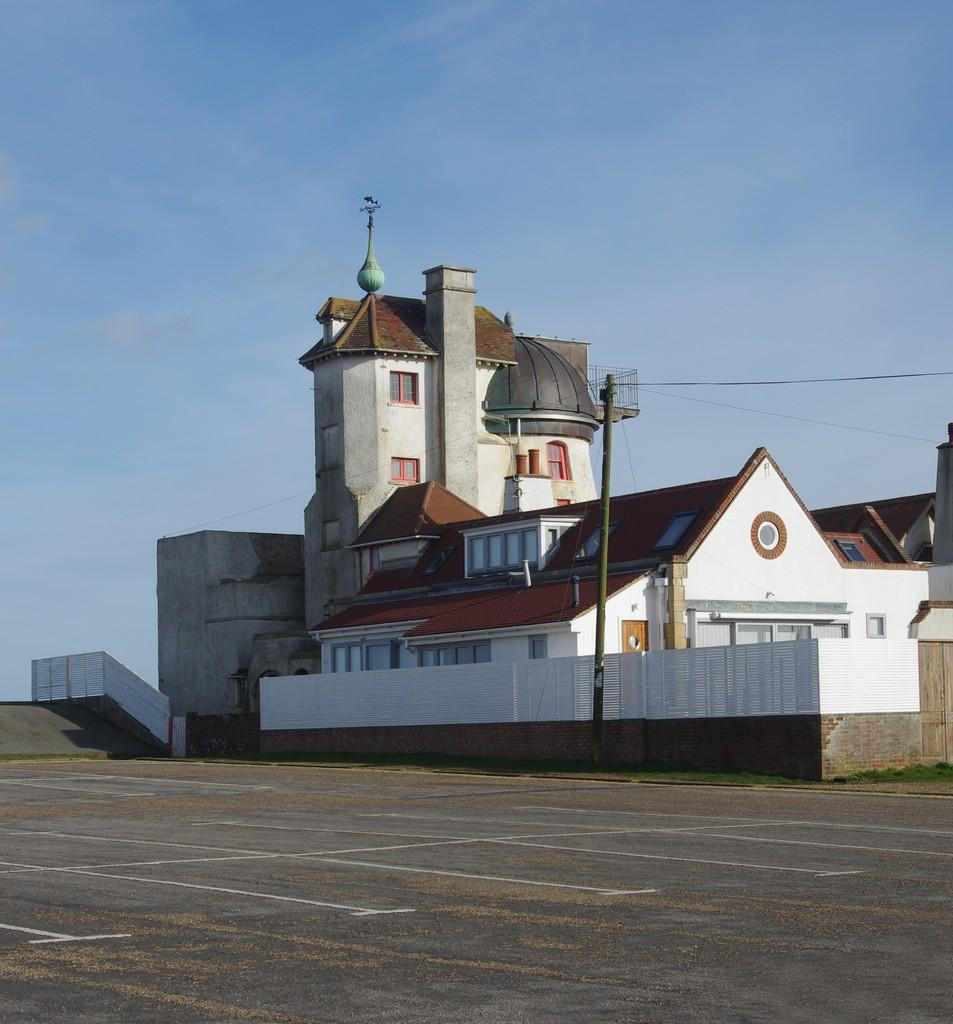What is the main feature of the image? There is a road in the image. What else can be seen in the image besides the road? There is a metal pole, wires, a building, and the sky visible in the image. Can you describe the building in the image? The building has white, brown, and orange colors. What is the color of the sky in the background of the image? The sky is visible in the background of the image, but the color is not mentioned in the facts. How many kittens are playing with the metal pole in the image? There are no kittens present in the image. What type of iron is used to make the wires in the image? The facts do not mention the type of metal used for the wires, and there is no iron present in the image. 